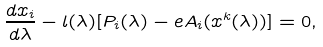<formula> <loc_0><loc_0><loc_500><loc_500>\frac { d x _ { i } } { d \lambda } - l ( \lambda ) [ P _ { i } ( \lambda ) - e A _ { i } ( x ^ { k } ( \lambda ) ) ] = 0 ,</formula> 